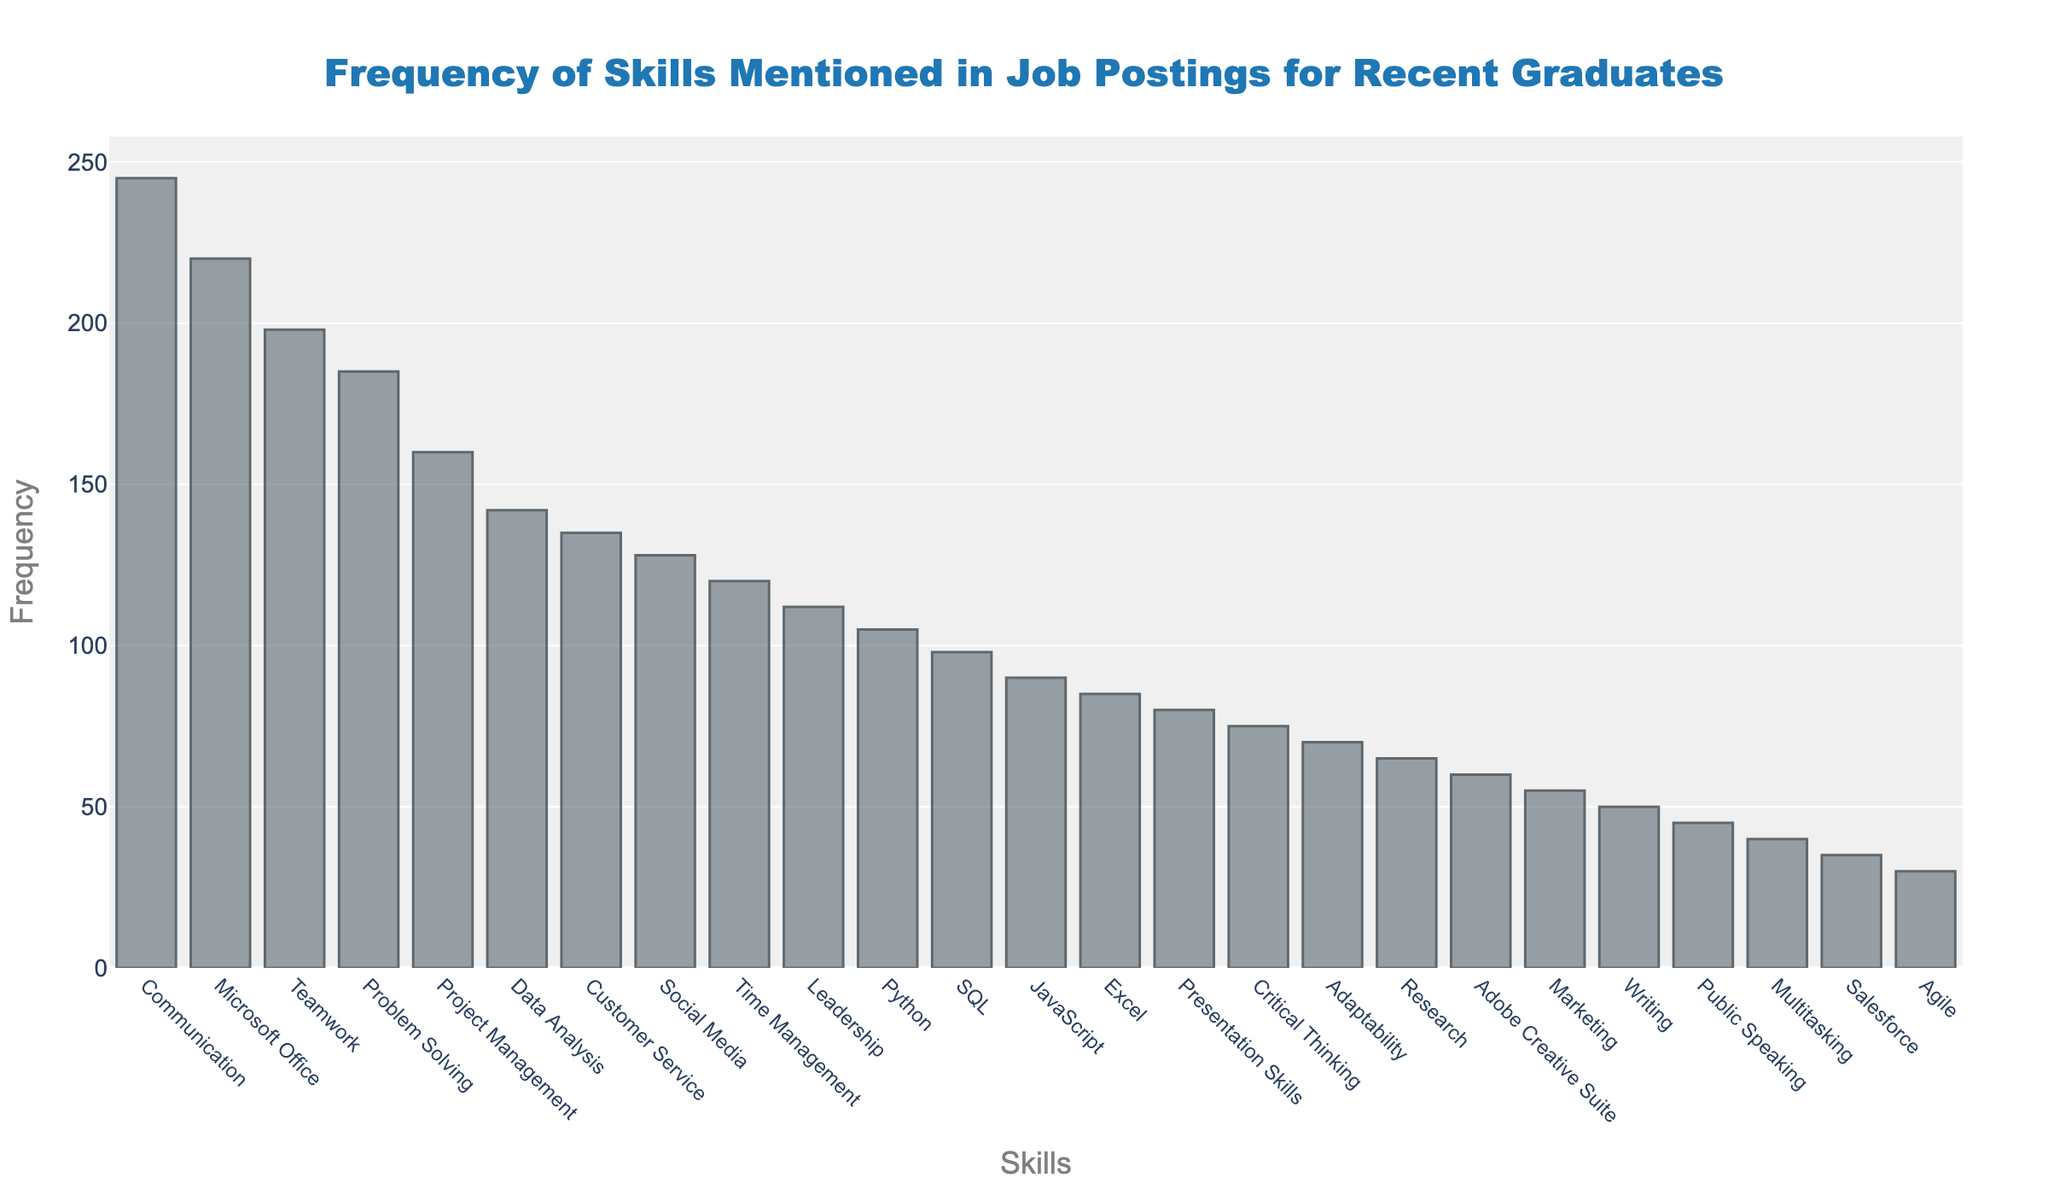What is the most frequently mentioned skill in the job postings? The bar representing each skill indicates that "Communication" has the highest bar, implying it is the most frequently mentioned skill.
Answer: Communication How many times is "Python" mentioned in job postings? Locate the bar for "Python" and read its height value on the y-axis, which shows 105.
Answer: 105 Which skill is mentioned more frequently, "SQL" or "JavaScript"? Compare the heights of the bars for "SQL" and "JavaScript". "SQL" is slightly higher than "JavaScript".
Answer: SQL What is the total frequency of mentions for "Project Management", "Data Analysis", and "Customer Service"? Sum the y-axis values for these skills: 160 (Project Management) + 142 (Data Analysis) + 135 (Customer Service) = 437.
Answer: 437 Which skill has a mention frequency closest to 100? Check the skills whose bars are close to the 100 mark on the y-axis. "Python" has a frequency of 105.
Answer: Python By how much does the frequency of "Teamwork" exceed that of "Problem Solving"? Subtract the frequency of "Problem Solving" (185) from "Teamwork" (198): 198 - 185 = 13.
Answer: 13 What is the median frequency of all the mentioned skills? Arrange the frequencies in ascending order and find the middle value. Since there are 25 skills, the median is the 13th value, which is 90 (JavaScript).
Answer: 90 What is the frequency difference between the most mentioned skill and the least mentioned skill? Subtract the frequency of the least mentioned skill "Agile" (30) from the most mentioned skill "Communication" (245): 245 - 30 = 215.
Answer: 215 Which two skills have the exact same frequency? From the figure, identify that "Teamwork" and "Problem Solving" (both around 185) do not have the exact same frequency. Upon closer inspection, no two skills have exactly the same frequency.
Answer: None Which skill is mentioned slightly more frequently than "Excel"? Look at the skills listed after "Excel" and note that "JavaScript" has a slight higher frequency at 90 compared to "Excel" at 85.
Answer: JavaScript 